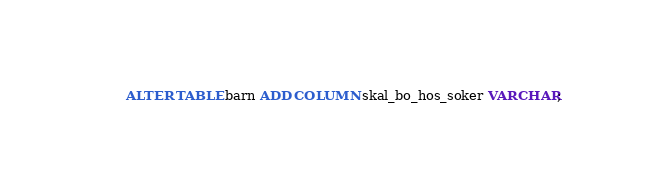Convert code to text. <code><loc_0><loc_0><loc_500><loc_500><_SQL_>ALTER TABLE barn ADD COLUMN skal_bo_hos_soker VARCHAR;</code> 